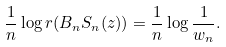Convert formula to latex. <formula><loc_0><loc_0><loc_500><loc_500>\frac { 1 } { n } \log r ( B _ { n } S _ { n } ( z ) ) = \frac { 1 } { n } \log \frac { 1 } { w _ { n } } .</formula> 